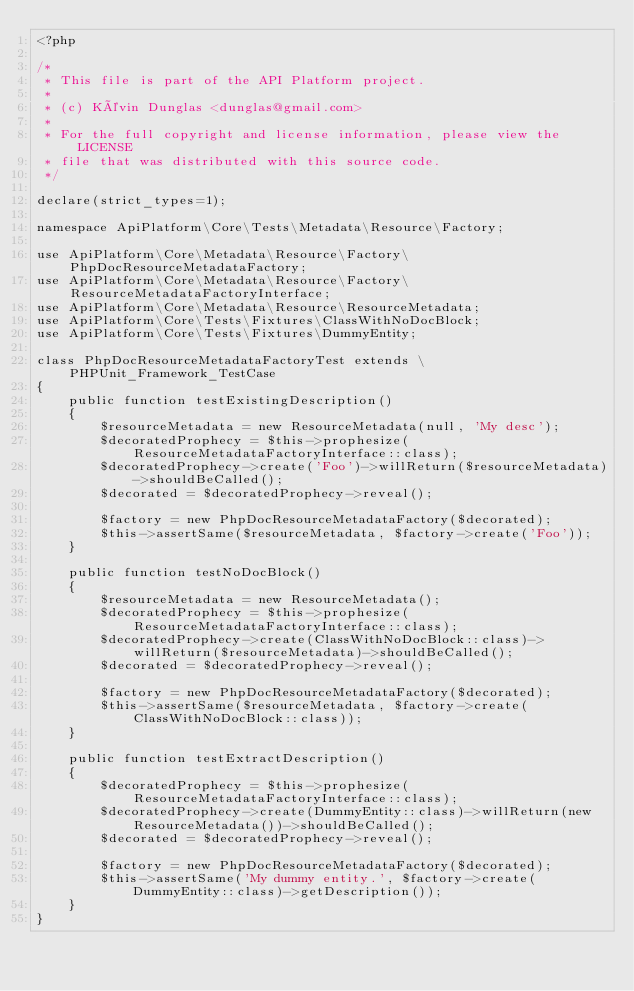<code> <loc_0><loc_0><loc_500><loc_500><_PHP_><?php

/*
 * This file is part of the API Platform project.
 *
 * (c) Kévin Dunglas <dunglas@gmail.com>
 *
 * For the full copyright and license information, please view the LICENSE
 * file that was distributed with this source code.
 */

declare(strict_types=1);

namespace ApiPlatform\Core\Tests\Metadata\Resource\Factory;

use ApiPlatform\Core\Metadata\Resource\Factory\PhpDocResourceMetadataFactory;
use ApiPlatform\Core\Metadata\Resource\Factory\ResourceMetadataFactoryInterface;
use ApiPlatform\Core\Metadata\Resource\ResourceMetadata;
use ApiPlatform\Core\Tests\Fixtures\ClassWithNoDocBlock;
use ApiPlatform\Core\Tests\Fixtures\DummyEntity;

class PhpDocResourceMetadataFactoryTest extends \PHPUnit_Framework_TestCase
{
    public function testExistingDescription()
    {
        $resourceMetadata = new ResourceMetadata(null, 'My desc');
        $decoratedProphecy = $this->prophesize(ResourceMetadataFactoryInterface::class);
        $decoratedProphecy->create('Foo')->willReturn($resourceMetadata)->shouldBeCalled();
        $decorated = $decoratedProphecy->reveal();

        $factory = new PhpDocResourceMetadataFactory($decorated);
        $this->assertSame($resourceMetadata, $factory->create('Foo'));
    }

    public function testNoDocBlock()
    {
        $resourceMetadata = new ResourceMetadata();
        $decoratedProphecy = $this->prophesize(ResourceMetadataFactoryInterface::class);
        $decoratedProphecy->create(ClassWithNoDocBlock::class)->willReturn($resourceMetadata)->shouldBeCalled();
        $decorated = $decoratedProphecy->reveal();

        $factory = new PhpDocResourceMetadataFactory($decorated);
        $this->assertSame($resourceMetadata, $factory->create(ClassWithNoDocBlock::class));
    }

    public function testExtractDescription()
    {
        $decoratedProphecy = $this->prophesize(ResourceMetadataFactoryInterface::class);
        $decoratedProphecy->create(DummyEntity::class)->willReturn(new ResourceMetadata())->shouldBeCalled();
        $decorated = $decoratedProphecy->reveal();

        $factory = new PhpDocResourceMetadataFactory($decorated);
        $this->assertSame('My dummy entity.', $factory->create(DummyEntity::class)->getDescription());
    }
}
</code> 